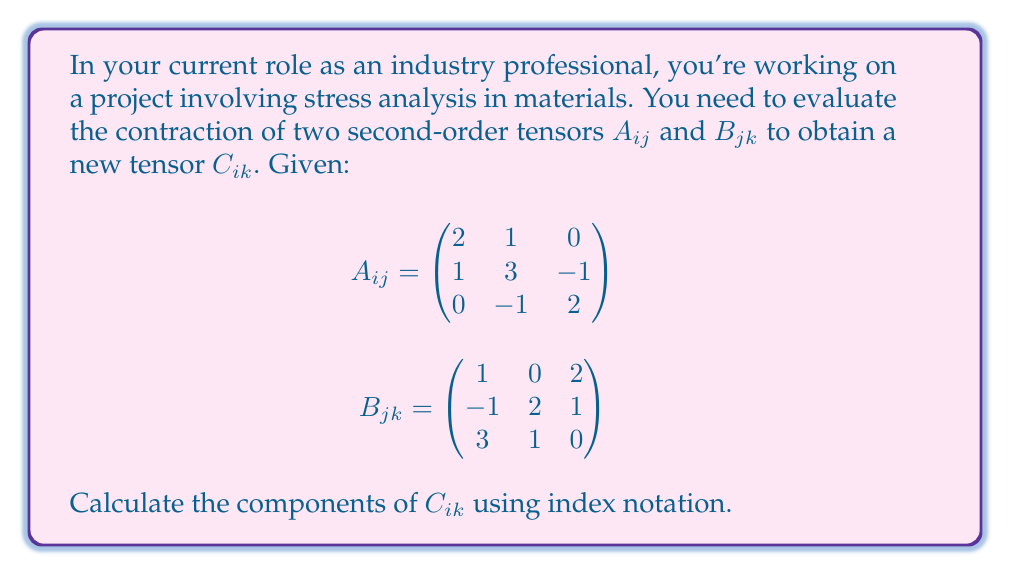Teach me how to tackle this problem. To evaluate the contraction of two tensors $A_{ij}$ and $B_{jk}$ in index notation, we use the formula:

$$C_{ik} = A_{ij}B_{jk}$$

This means we need to sum over the repeated index $j$. Let's calculate each component of $C_{ik}$:

1) For $C_{11}$:
   $$C_{11} = A_{1j}B_{j1} = A_{11}B_{11} + A_{12}B_{21} + A_{13}B_{31} = (2)(1) + (1)(-1) + (0)(3) = 1$$

2) For $C_{12}$:
   $$C_{12} = A_{1j}B_{j2} = A_{11}B_{12} + A_{12}B_{22} + A_{13}B_{32} = (2)(0) + (1)(2) + (0)(1) = 2$$

3) For $C_{13}$:
   $$C_{13} = A_{1j}B_{j3} = A_{11}B_{13} + A_{12}B_{23} + A_{13}B_{33} = (2)(2) + (1)(1) + (0)(0) = 5$$

4) For $C_{21}$:
   $$C_{21} = A_{2j}B_{j1} = A_{21}B_{11} + A_{22}B_{21} + A_{23}B_{31} = (1)(1) + (3)(-1) + (-1)(3) = -5$$

5) For $C_{22}$:
   $$C_{22} = A_{2j}B_{j2} = A_{21}B_{12} + A_{22}B_{22} + A_{23}B_{32} = (1)(0) + (3)(2) + (-1)(1) = 5$$

6) For $C_{23}$:
   $$C_{23} = A_{2j}B_{j3} = A_{21}B_{13} + A_{22}B_{23} + A_{23}B_{33} = (1)(2) + (3)(1) + (-1)(0) = 5$$

7) For $C_{31}$:
   $$C_{31} = A_{3j}B_{j1} = A_{31}B_{11} + A_{32}B_{21} + A_{33}B_{31} = (0)(1) + (-1)(-1) + (2)(3) = 7$$

8) For $C_{32}$:
   $$C_{32} = A_{3j}B_{j2} = A_{31}B_{12} + A_{32}B_{22} + A_{33}B_{32} = (0)(0) + (-1)(2) + (2)(1) = 0$$

9) For $C_{33}$:
   $$C_{33} = A_{3j}B_{j3} = A_{31}B_{13} + A_{32}B_{23} + A_{33}B_{33} = (0)(2) + (-1)(1) + (2)(0) = -1$$

Therefore, the resulting tensor $C_{ik}$ is:

$$C_{ik} = \begin{pmatrix}
1 & 2 & 5 \\
-5 & 5 & 5 \\
7 & 0 & -1
\end{pmatrix}$$
Answer: $$C_{ik} = \begin{pmatrix}
1 & 2 & 5 \\
-5 & 5 & 5 \\
7 & 0 & -1
\end{pmatrix}$$ 